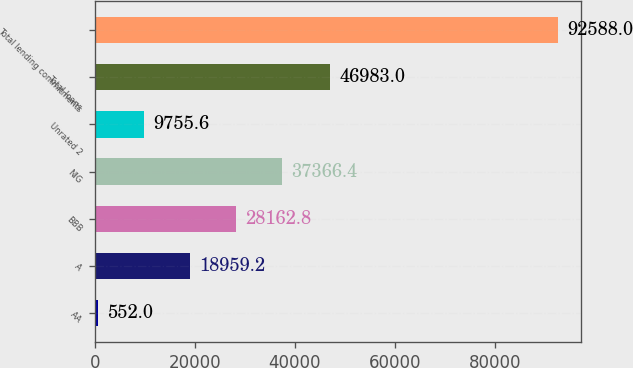Convert chart. <chart><loc_0><loc_0><loc_500><loc_500><bar_chart><fcel>AA<fcel>A<fcel>BBB<fcel>NIG<fcel>Unrated 2<fcel>Total loans<fcel>Total lending commitments<nl><fcel>552<fcel>18959.2<fcel>28162.8<fcel>37366.4<fcel>9755.6<fcel>46983<fcel>92588<nl></chart> 